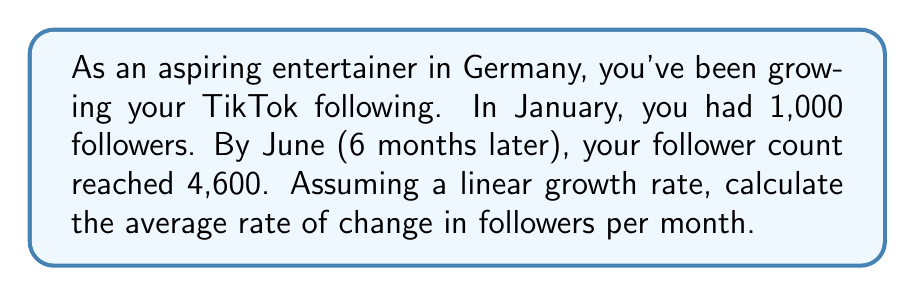Could you help me with this problem? To solve this problem, we'll use the rate of change formula:

$$ \text{Rate of Change} = \frac{\text{Change in y}}{\text{Change in x}} $$

Where y represents the number of followers and x represents the time in months.

1. Identify the initial and final values:
   - Initial followers (January): 1,000
   - Final followers (June): 4,600
   - Time span: 6 months

2. Calculate the change in followers:
   $$ \text{Change in followers} = 4,600 - 1,000 = 3,600 $$

3. Apply the rate of change formula:
   $$ \text{Rate of Change} = \frac{4,600 - 1,000}{6 - 0} = \frac{3,600}{6} = 600 $$

This means you gained an average of 600 followers per month.
Answer: The average rate of change in followers is 600 per month. 